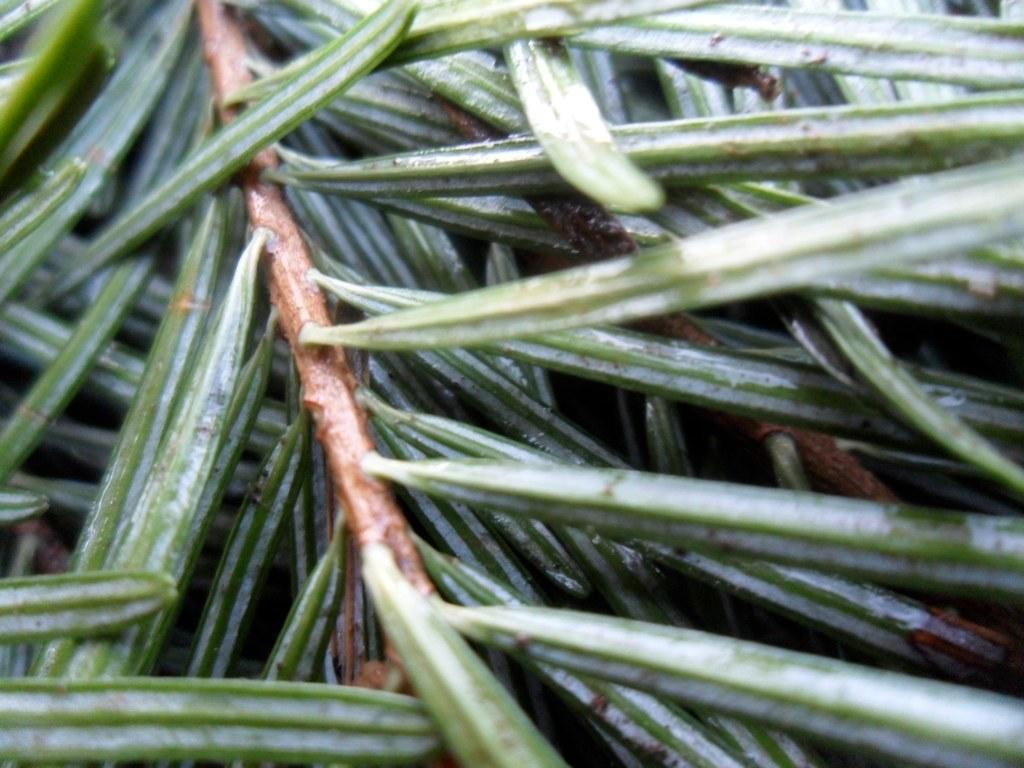What is the focus of the image? The image is a zoomed in picture. What type of plant material can be seen in the image? There are leaves and stems in the image. What type of chairs are visible in the image? There are no chairs present in the image; it features a close-up view of plant material. What country is the image taken in? The provided facts do not mention the country where the image was taken, so it cannot be determined from the information given. 